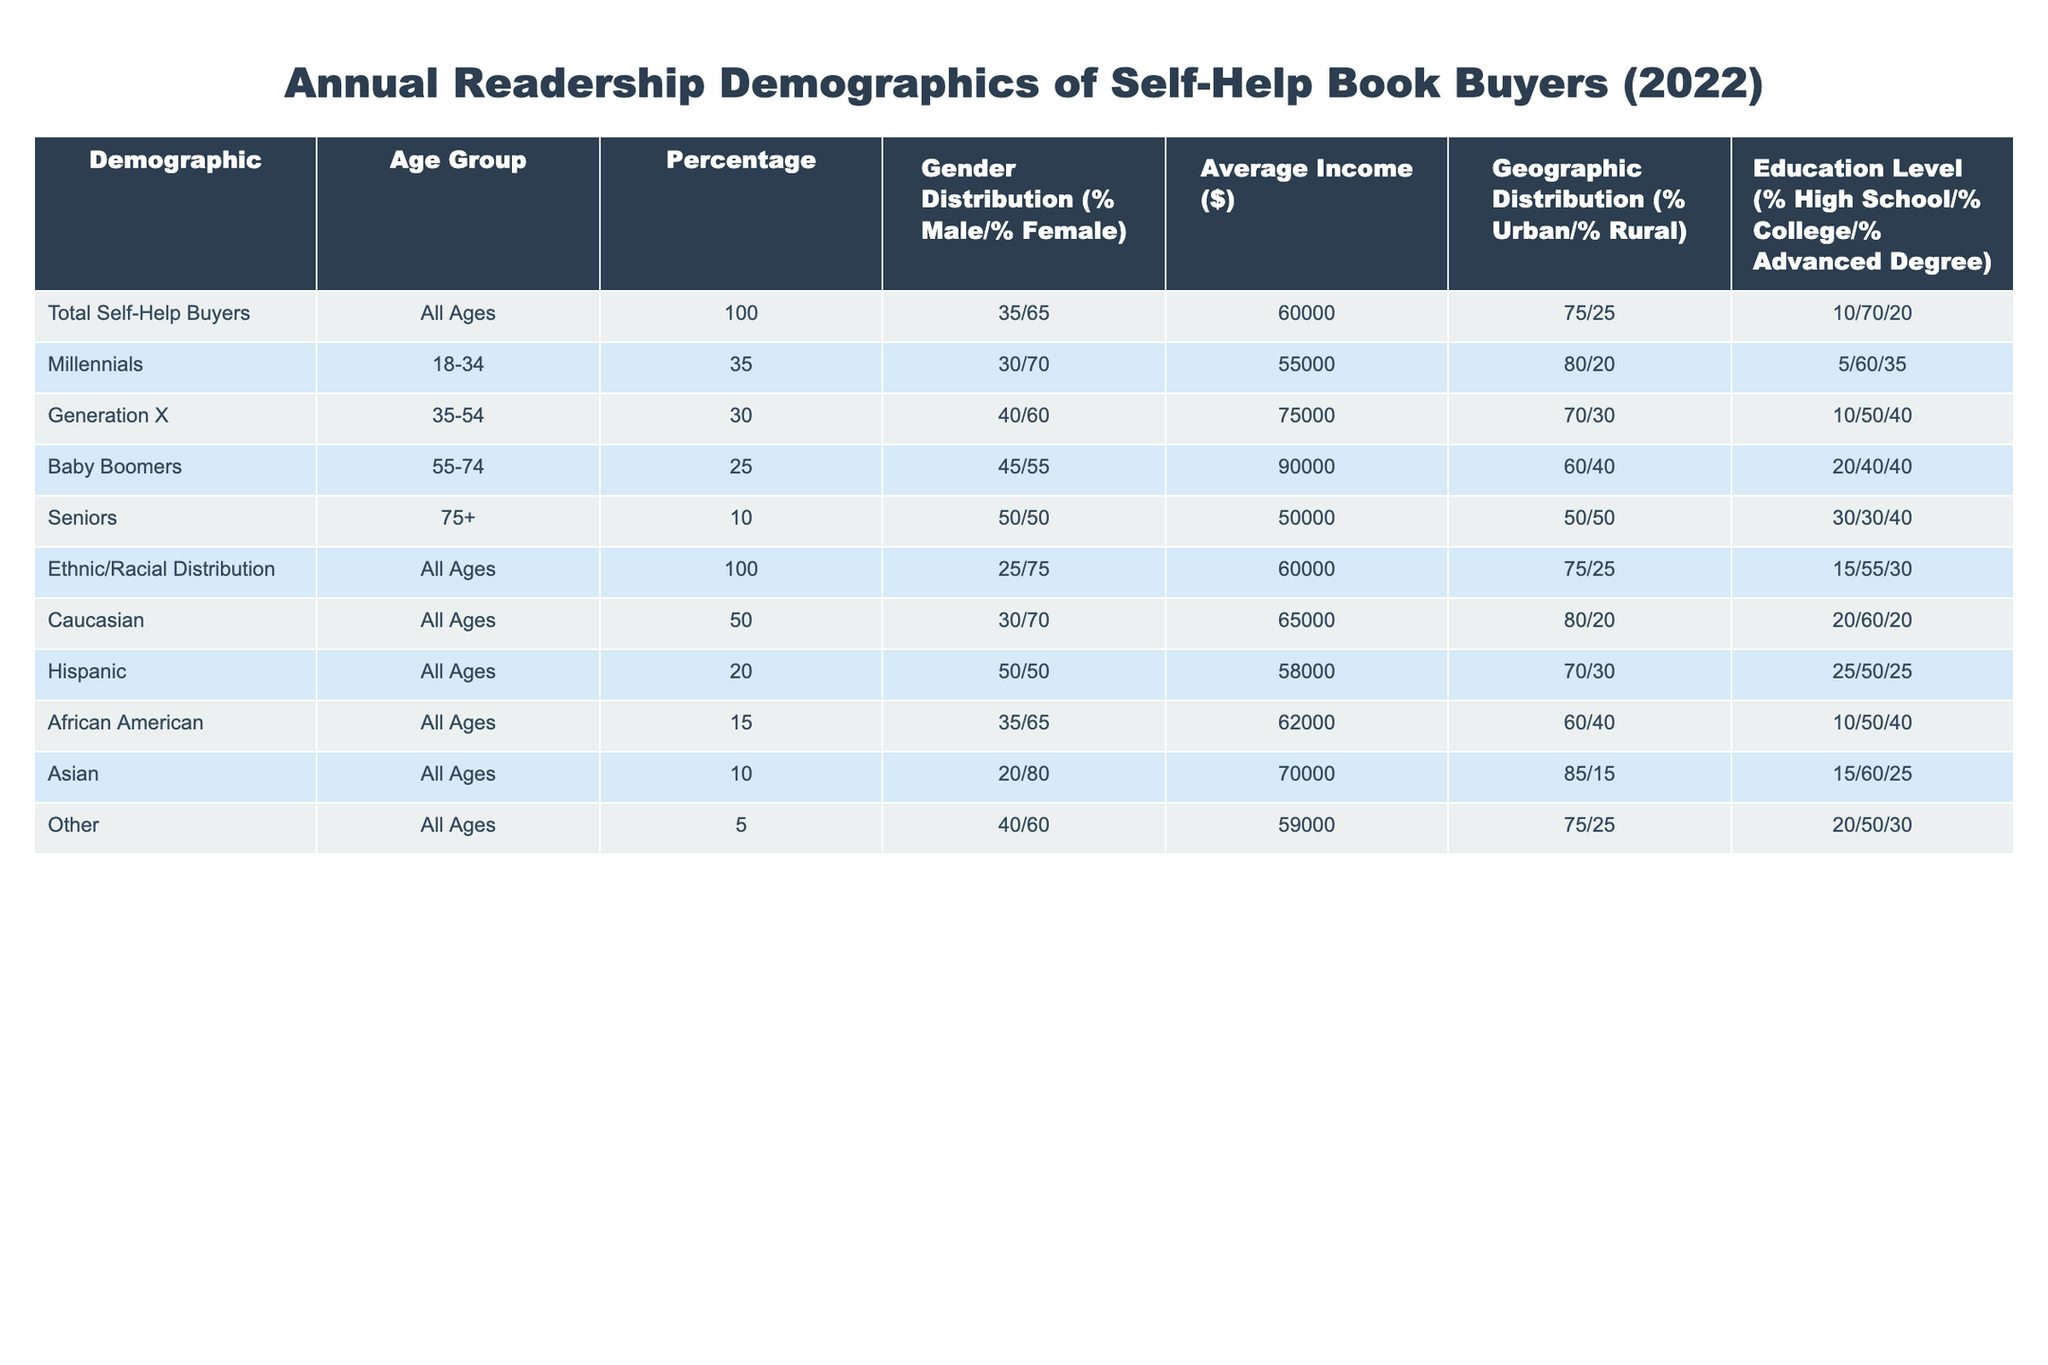What percentage of self-help book buyers are from the Millennial age group? The table indicates that Millennials (aged 18-34) make up 35% of all self-help book buyers.
Answer: 35% What is the average income of Baby Boomers who purchase self-help books? According to the table, Baby Boomers (aged 55-74) have an average income of $90,000.
Answer: $90,000 True or False: The percentage of males in the Hispanic demographic is higher than that of African American self-help book buyers. The table shows that the gender distribution for Hispanics is 50% male and 50% female, while for African Americans it is 35% male and 65% female. This means the percentage of males is higher in the Hispanic group.
Answer: True What is the average income difference between Generation X and Seniors? Generation X has an average income of $75,000, while Seniors have an average income of $50,000. The difference is $75,000 - $50,000 = $25,000.
Answer: $25,000 What proportion of self-help book buyers have an advanced degree across all age groups? The table shows that 20% of self-help book buyers hold an advanced degree when considering the total across all ages.
Answer: 20% Which age group has the highest percentage of urban dwellers among self-help book buyers? The table indicates that Millennials have the highest percentage of urban dwellers at 80%.
Answer: Millennials True or False: The educational level of self-help book buyers is more skewed toward high school education than advanced degrees. The total educational level percentage shows 10% high school, 70% college, and 20% advanced degree. Clearly, the majority have a college education, thus making this statement false.
Answer: False How many self-help book buyers are there from the ethnic category “Other”? According to the table, the demographic labeled as "Other" comprises 5% of the total self-help buyers.
Answer: 5% What is the sum of percentages of males in both Millennials and Generation X? Millennial males represent 30%, and Generation X males represent 40%. So, the sum is 30% + 40% = 70%.
Answer: 70% 